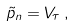<formula> <loc_0><loc_0><loc_500><loc_500>\tilde { p } _ { n } = V _ { \tau } \, ,</formula> 